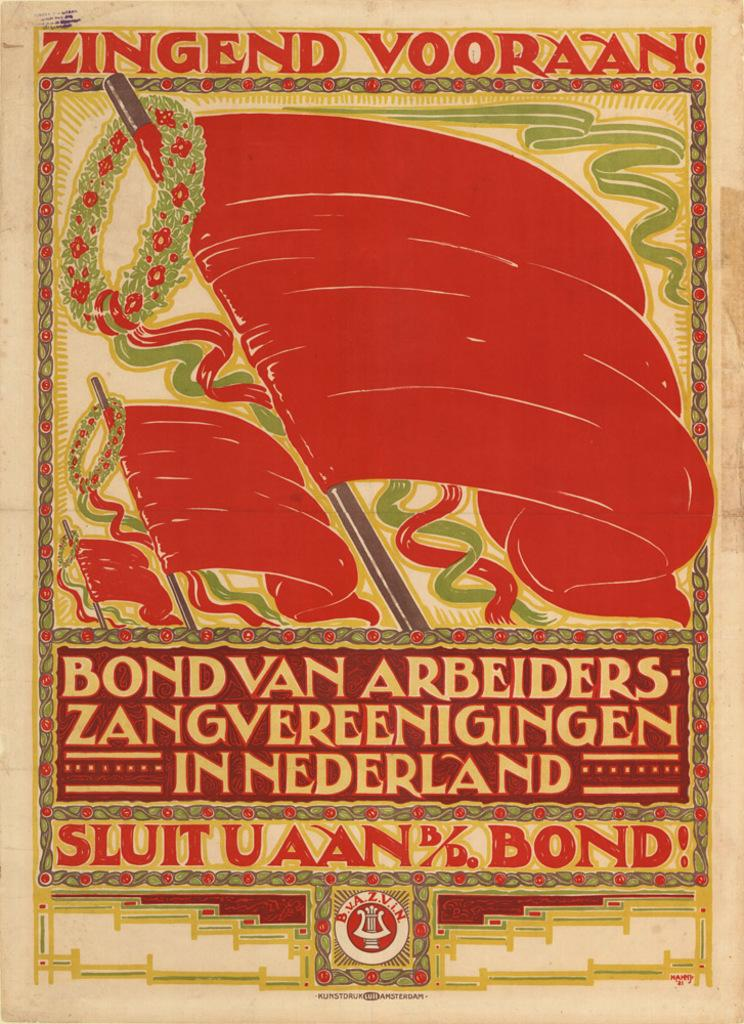<image>
Provide a brief description of the given image. A Zingend Vooraan picture with red flags on it 